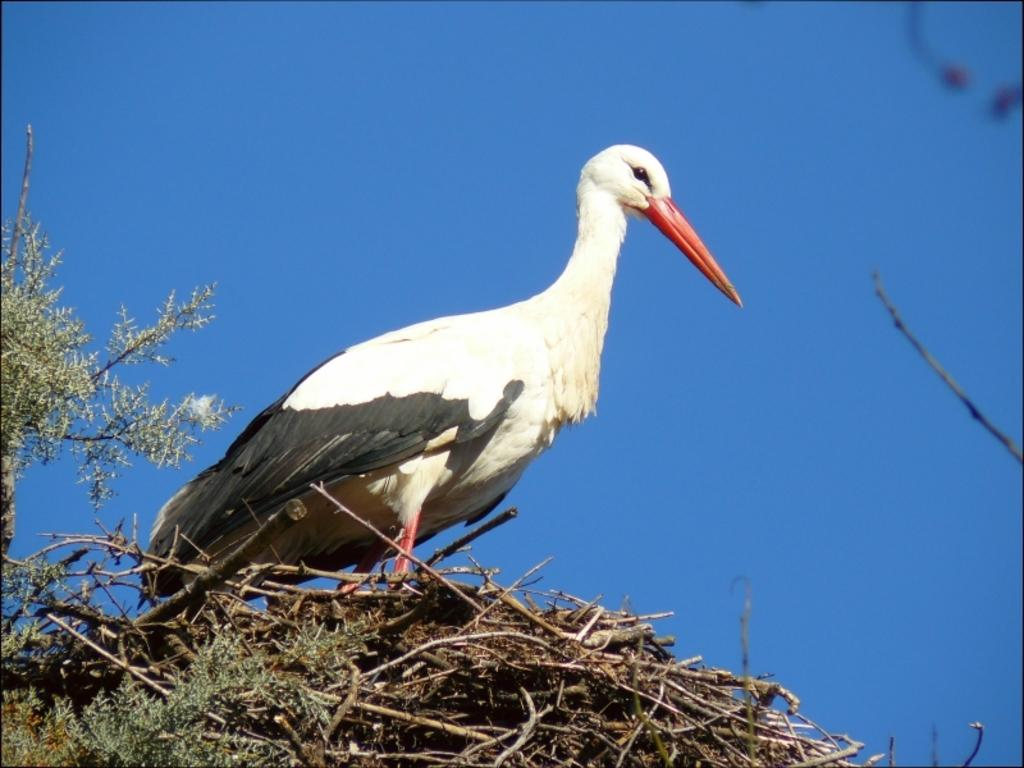What type of animal can be seen in the image? There is a bird in the image. What other elements are present in the image besides the bird? There are plants and sticks in the image. What can be seen in the background of the image? The sky is visible in the background of the image. How many lizards are exchanging ideas in the image? There are no lizards present in the image, and they are not exchanging ideas. 